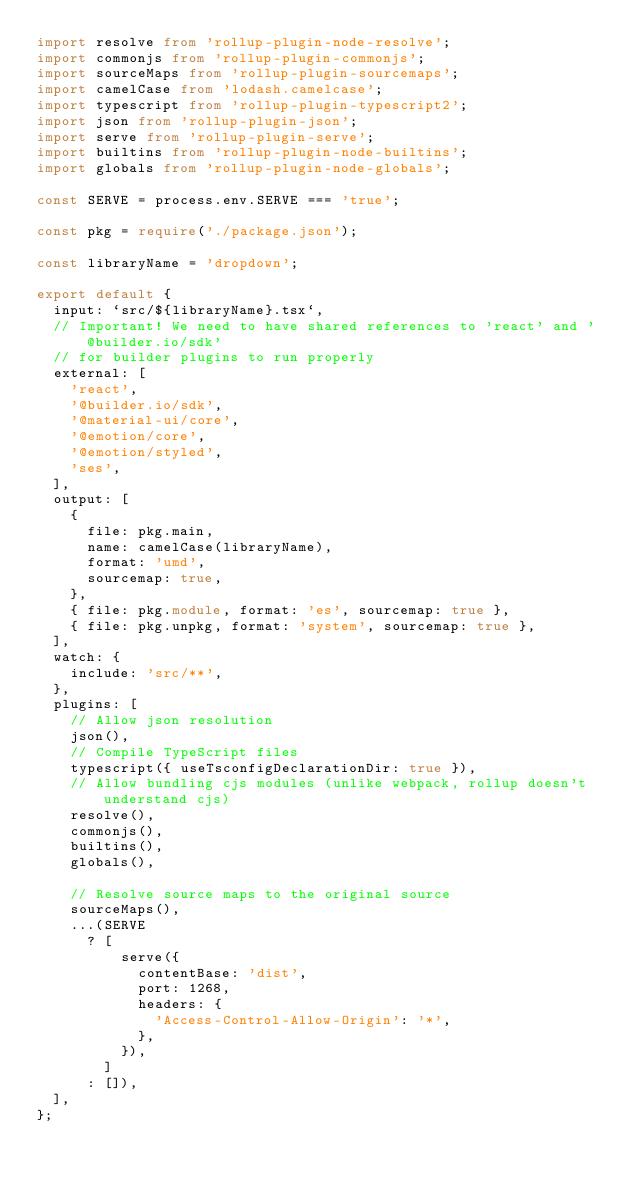<code> <loc_0><loc_0><loc_500><loc_500><_TypeScript_>import resolve from 'rollup-plugin-node-resolve';
import commonjs from 'rollup-plugin-commonjs';
import sourceMaps from 'rollup-plugin-sourcemaps';
import camelCase from 'lodash.camelcase';
import typescript from 'rollup-plugin-typescript2';
import json from 'rollup-plugin-json';
import serve from 'rollup-plugin-serve';
import builtins from 'rollup-plugin-node-builtins';
import globals from 'rollup-plugin-node-globals';

const SERVE = process.env.SERVE === 'true';

const pkg = require('./package.json');

const libraryName = 'dropdown';

export default {
  input: `src/${libraryName}.tsx`,
  // Important! We need to have shared references to 'react' and '@builder.io/sdk'
  // for builder plugins to run properly
  external: [
    'react',
    '@builder.io/sdk',
    '@material-ui/core',
    '@emotion/core',
    '@emotion/styled',
    'ses',
  ],
  output: [
    {
      file: pkg.main,
      name: camelCase(libraryName),
      format: 'umd',
      sourcemap: true,
    },
    { file: pkg.module, format: 'es', sourcemap: true },
    { file: pkg.unpkg, format: 'system', sourcemap: true },
  ],
  watch: {
    include: 'src/**',
  },
  plugins: [
    // Allow json resolution
    json(),
    // Compile TypeScript files
    typescript({ useTsconfigDeclarationDir: true }),
    // Allow bundling cjs modules (unlike webpack, rollup doesn't understand cjs)
    resolve(),
    commonjs(),
    builtins(),
    globals(),

    // Resolve source maps to the original source
    sourceMaps(),
    ...(SERVE
      ? [
          serve({
            contentBase: 'dist',
            port: 1268,
            headers: {
              'Access-Control-Allow-Origin': '*',
            },
          }),
        ]
      : []),
  ],
};
</code> 